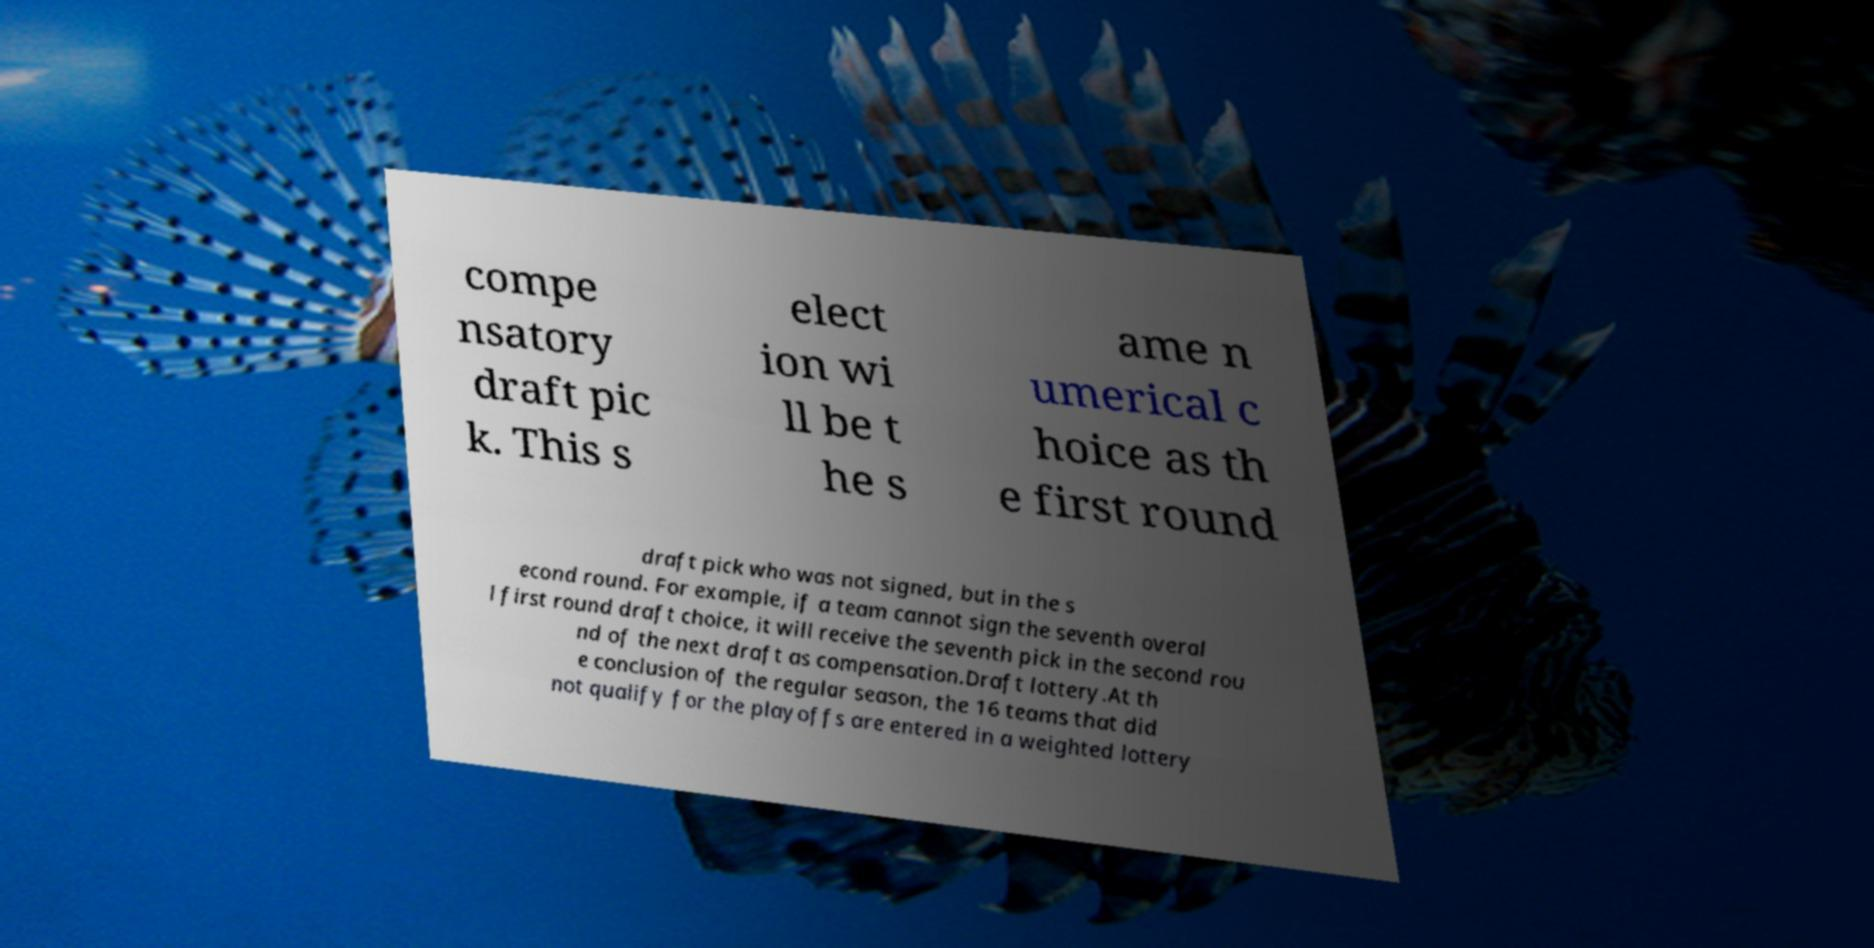Could you assist in decoding the text presented in this image and type it out clearly? compe nsatory draft pic k. This s elect ion wi ll be t he s ame n umerical c hoice as th e first round draft pick who was not signed, but in the s econd round. For example, if a team cannot sign the seventh overal l first round draft choice, it will receive the seventh pick in the second rou nd of the next draft as compensation.Draft lottery.At th e conclusion of the regular season, the 16 teams that did not qualify for the playoffs are entered in a weighted lottery 